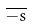<formula> <loc_0><loc_0><loc_500><loc_500>\overline { - s }</formula> 